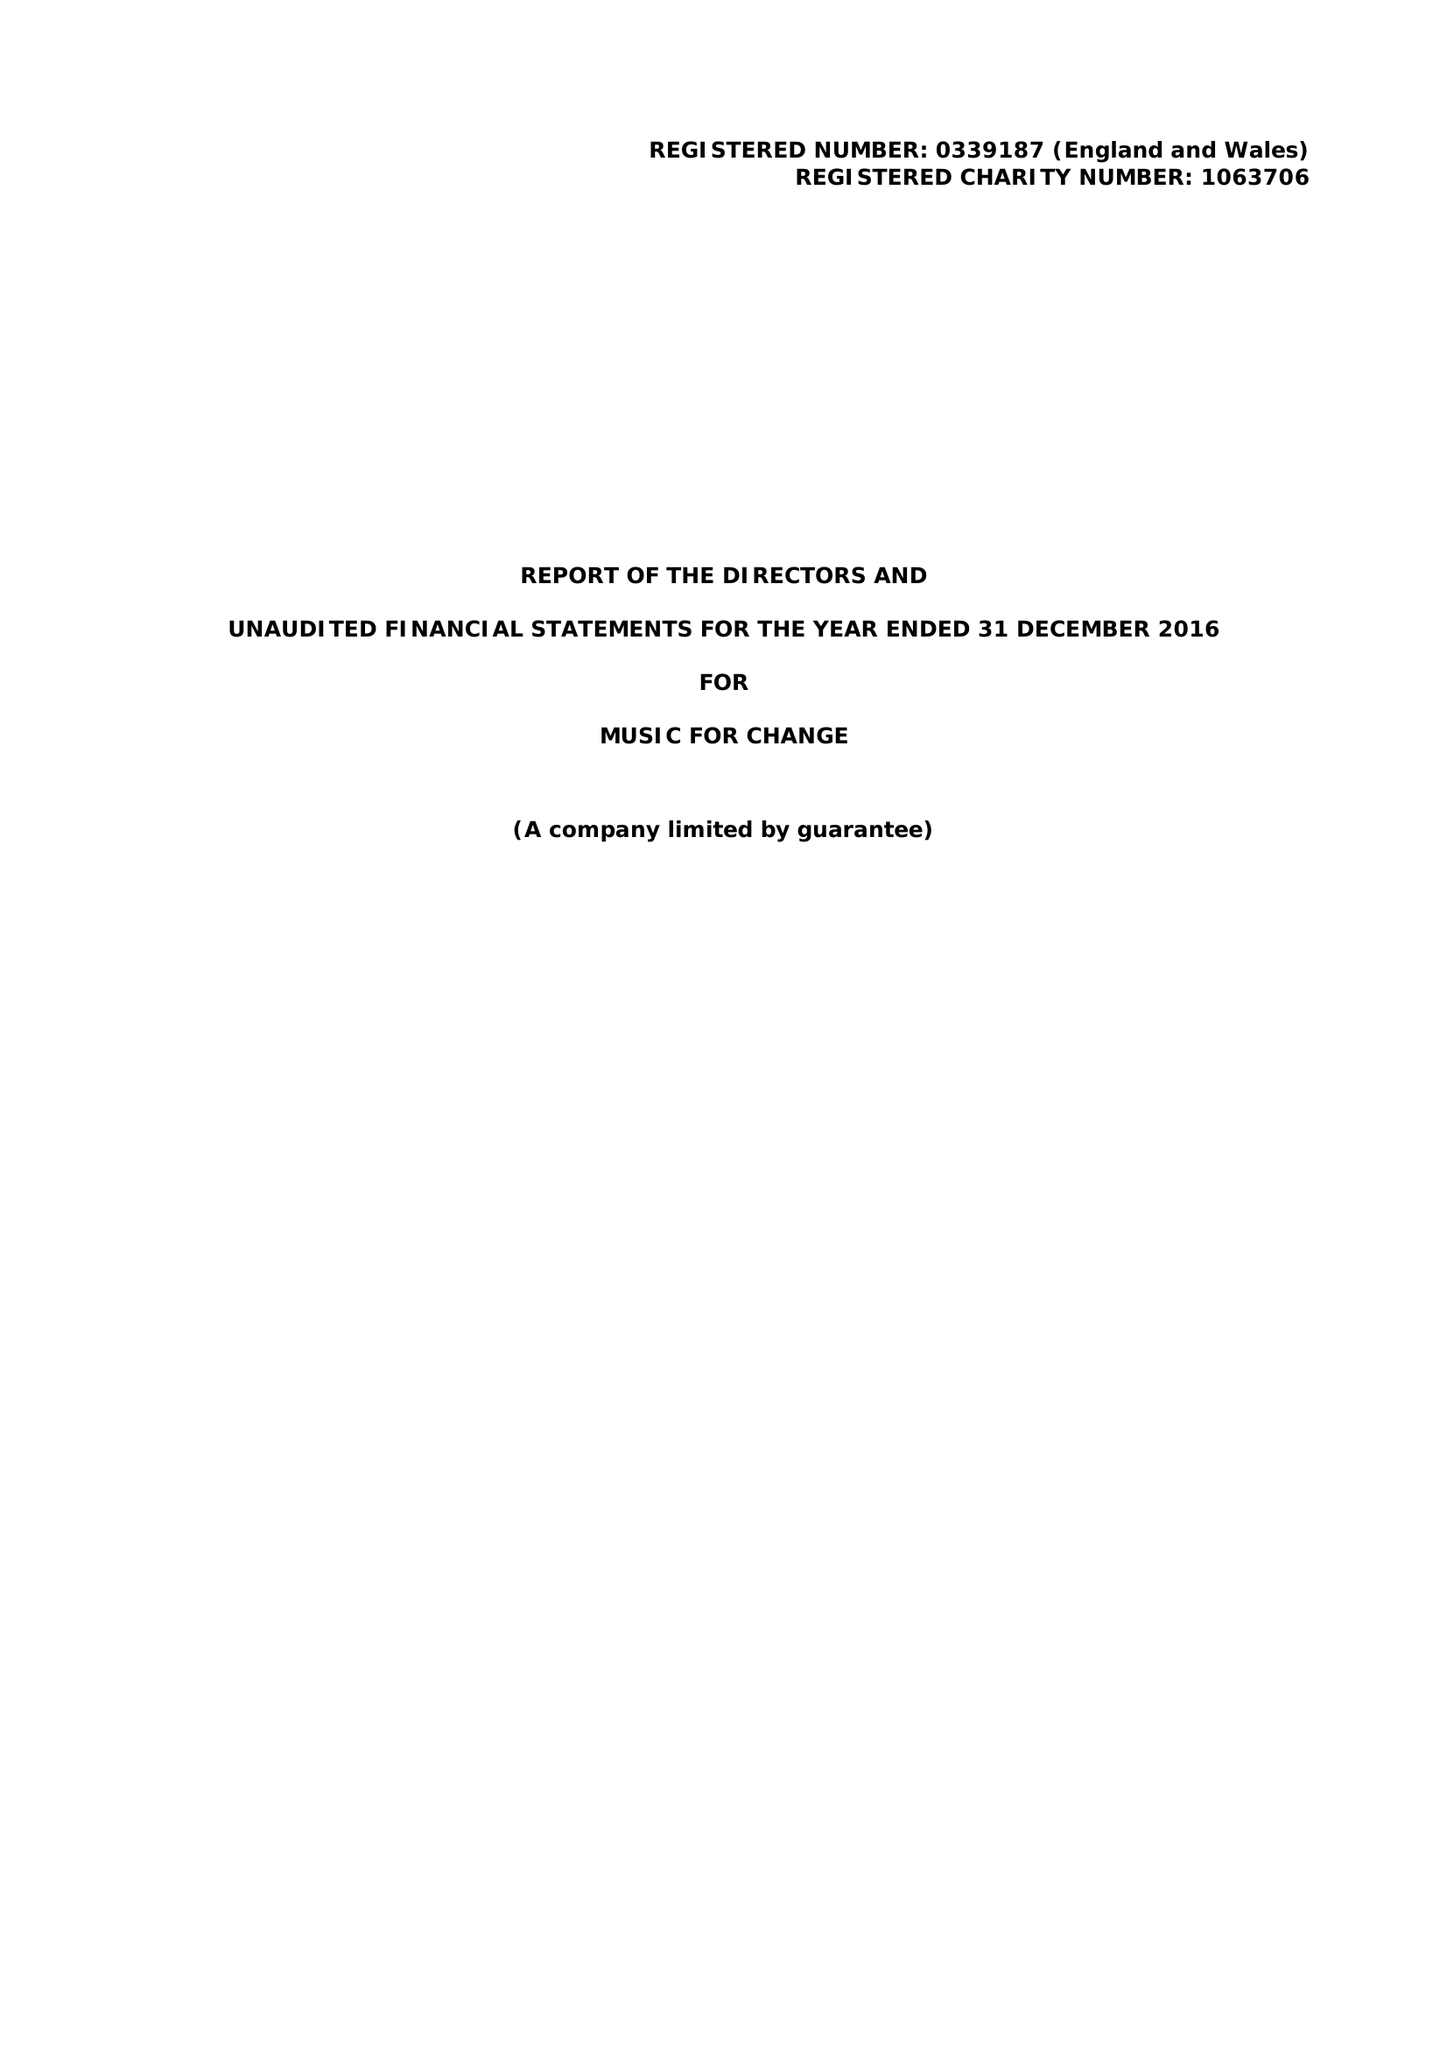What is the value for the address__post_town?
Answer the question using a single word or phrase. CANTERBURY 